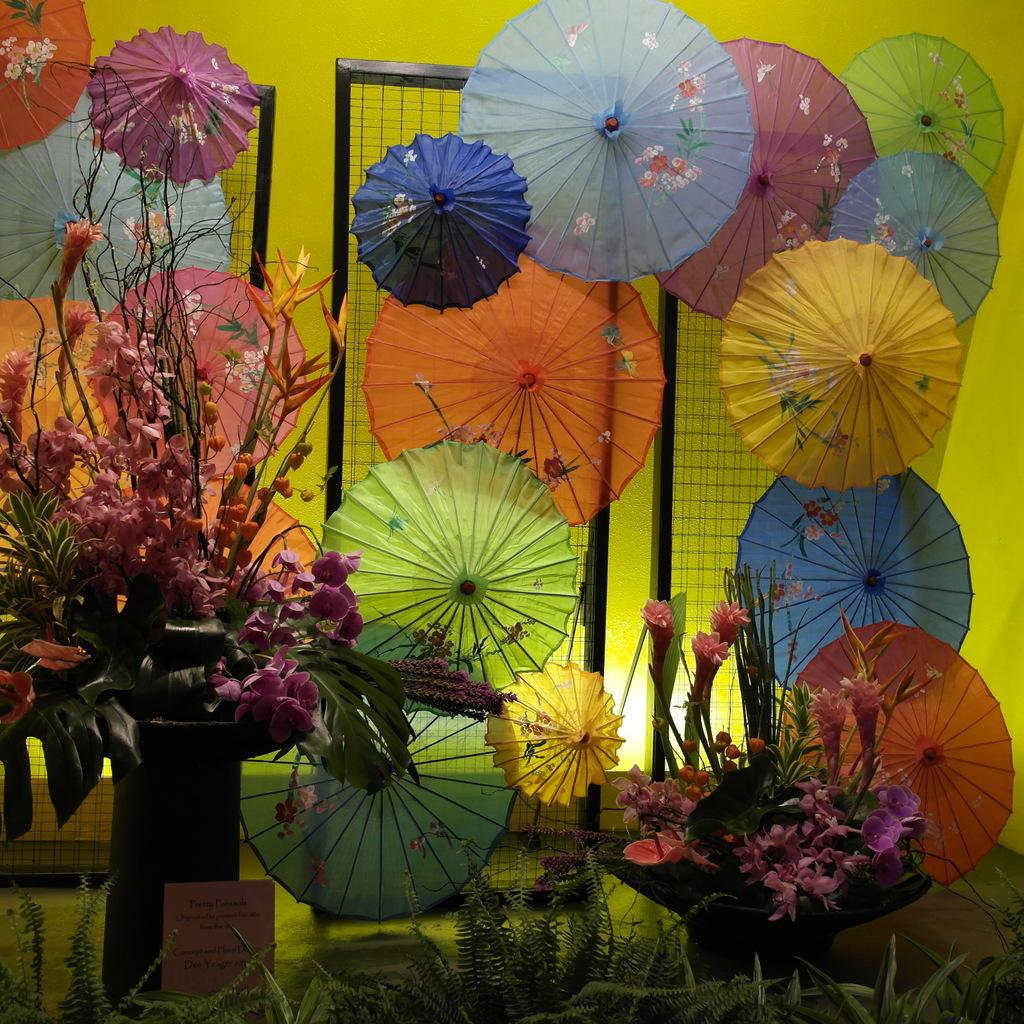What objects are grouped together in the image? There is a group of umbrellas in the image. What type of structure can be seen in the image? There are metal grills in the image. What is located in the foreground of the image? There is a group of flowers and plants in the foreground of the image. What is visible behind the umbrellas? There is a wall visible behind the umbrellas. What type of animal is seen performing a curve on the skate in the image? There is no animal or skate present in the image; it features a group of umbrellas, metal grills, and plants. 